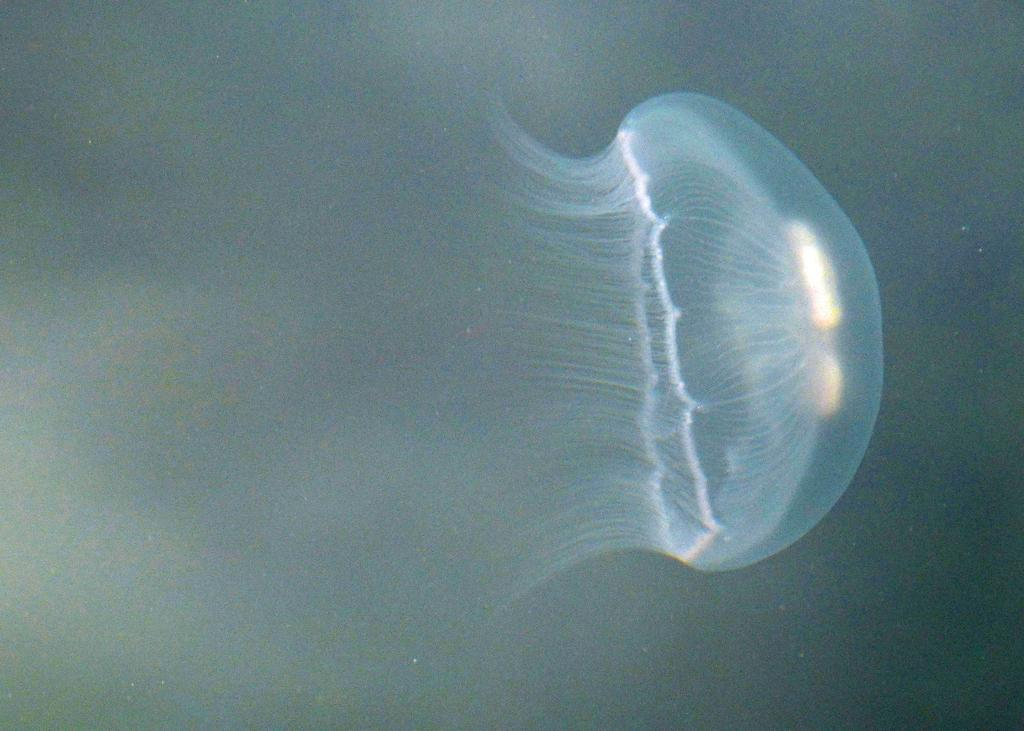What type of sea creatures are present in the image? There are jellyfish in the image. What type of pocket can be seen on the jellyfish in the image? There are no pockets present on the jellyfish in the image, as jellyfish do not have pockets. 